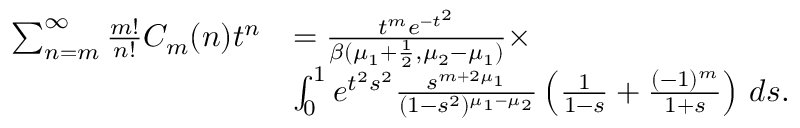Convert formula to latex. <formula><loc_0><loc_0><loc_500><loc_500>\begin{array} { r l } { \sum _ { n = m } ^ { \infty } \frac { m ! } { n ! } C _ { m } ( n ) t ^ { n } } & { = { \frac { t ^ { m } e ^ { - t ^ { 2 } } } { \beta ( \mu _ { 1 } + \frac { 1 } { 2 } , \mu _ { 2 } - \mu _ { 1 } ) } } \times } \\ & { \int _ { 0 } ^ { 1 } e ^ { t ^ { 2 } s ^ { 2 } } { \frac { s ^ { m + 2 \mu _ { 1 } } } { ( 1 - s ^ { 2 } ) ^ { \mu _ { 1 } - \mu _ { 2 } } } } \left ( { \frac { 1 } { 1 - s } } + { \frac { ( - 1 ) ^ { m } } { 1 + s } } \right ) \, d s . } \end{array}</formula> 